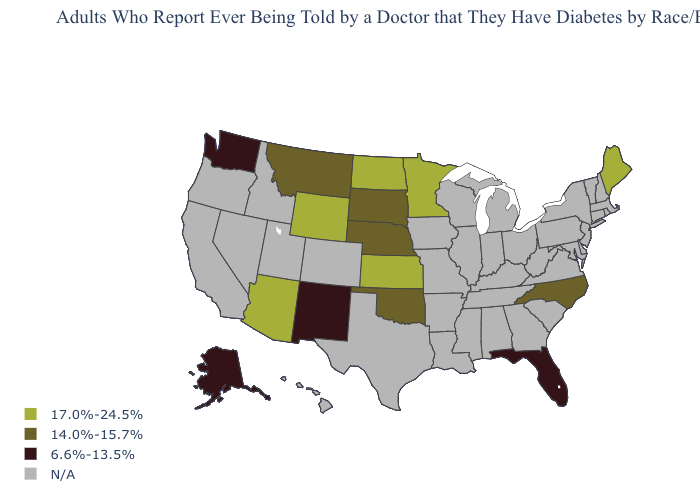What is the value of Washington?
Be succinct. 6.6%-13.5%. What is the highest value in the USA?
Concise answer only. 17.0%-24.5%. Name the states that have a value in the range 14.0%-15.7%?
Be succinct. Montana, Nebraska, North Carolina, Oklahoma, South Dakota. What is the value of Oregon?
Quick response, please. N/A. Name the states that have a value in the range 6.6%-13.5%?
Give a very brief answer. Alaska, Florida, New Mexico, Washington. Does South Dakota have the highest value in the MidWest?
Be succinct. No. Among the states that border South Dakota , which have the highest value?
Be succinct. Minnesota, North Dakota, Wyoming. Name the states that have a value in the range 6.6%-13.5%?
Answer briefly. Alaska, Florida, New Mexico, Washington. Name the states that have a value in the range N/A?
Short answer required. Alabama, Arkansas, California, Colorado, Connecticut, Delaware, Georgia, Hawaii, Idaho, Illinois, Indiana, Iowa, Kentucky, Louisiana, Maryland, Massachusetts, Michigan, Mississippi, Missouri, Nevada, New Hampshire, New Jersey, New York, Ohio, Oregon, Pennsylvania, Rhode Island, South Carolina, Tennessee, Texas, Utah, Vermont, Virginia, West Virginia, Wisconsin. Which states have the lowest value in the West?
Answer briefly. Alaska, New Mexico, Washington. What is the value of New Hampshire?
Give a very brief answer. N/A. Name the states that have a value in the range N/A?
Be succinct. Alabama, Arkansas, California, Colorado, Connecticut, Delaware, Georgia, Hawaii, Idaho, Illinois, Indiana, Iowa, Kentucky, Louisiana, Maryland, Massachusetts, Michigan, Mississippi, Missouri, Nevada, New Hampshire, New Jersey, New York, Ohio, Oregon, Pennsylvania, Rhode Island, South Carolina, Tennessee, Texas, Utah, Vermont, Virginia, West Virginia, Wisconsin. What is the value of Idaho?
Concise answer only. N/A. What is the value of South Dakota?
Concise answer only. 14.0%-15.7%. 